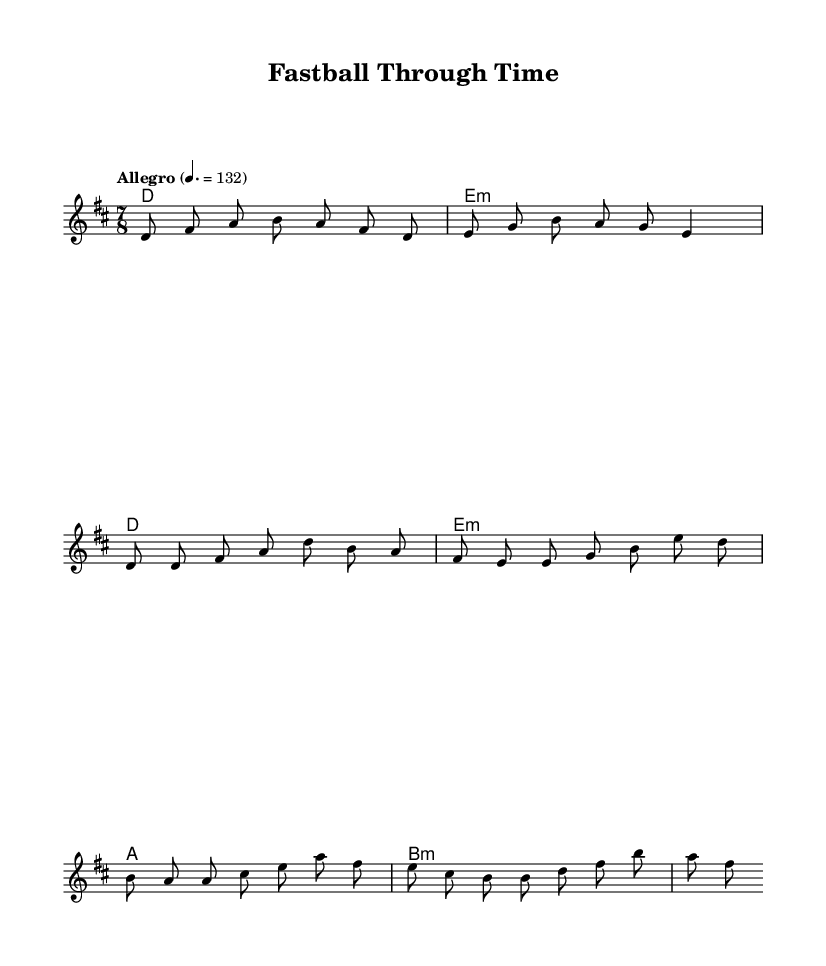What is the key signature of this music? The key signature shows two sharps, which indicates it is in D major. This is determined by looking at the key signature at the beginning of the staff.
Answer: D major What is the time signature of this music? The time signature is shown as 7/8 at the beginning of the piece. This means there are seven eighth notes per measure.
Answer: 7/8 What is the tempo marking of this piece? The tempo marking is indicated by "Allegro" followed by the metronome marking of 132 beats per minute. This suggests a fast-paced performance.
Answer: Allegro What is the chord for the intro section? The intro section starts with a D major chord, noted as d2.. in the harmonies. This specifies the harmonic foundation for the opening.
Answer: D major How many measures are in the chorus section? The chorus section is partially outlined in the sheet music and contains two measures, as indicated by the corresponding notes and harmonies.
Answer: 2 What type of fusion does this music represent? The music represents a fusion of traditional Appalachian folk and progressive rock, characterized by the blend of folk melodies with the complex rhythms typical of progressive rock.
Answer: Fusion of traditional Appalachian folk and progressive rock 